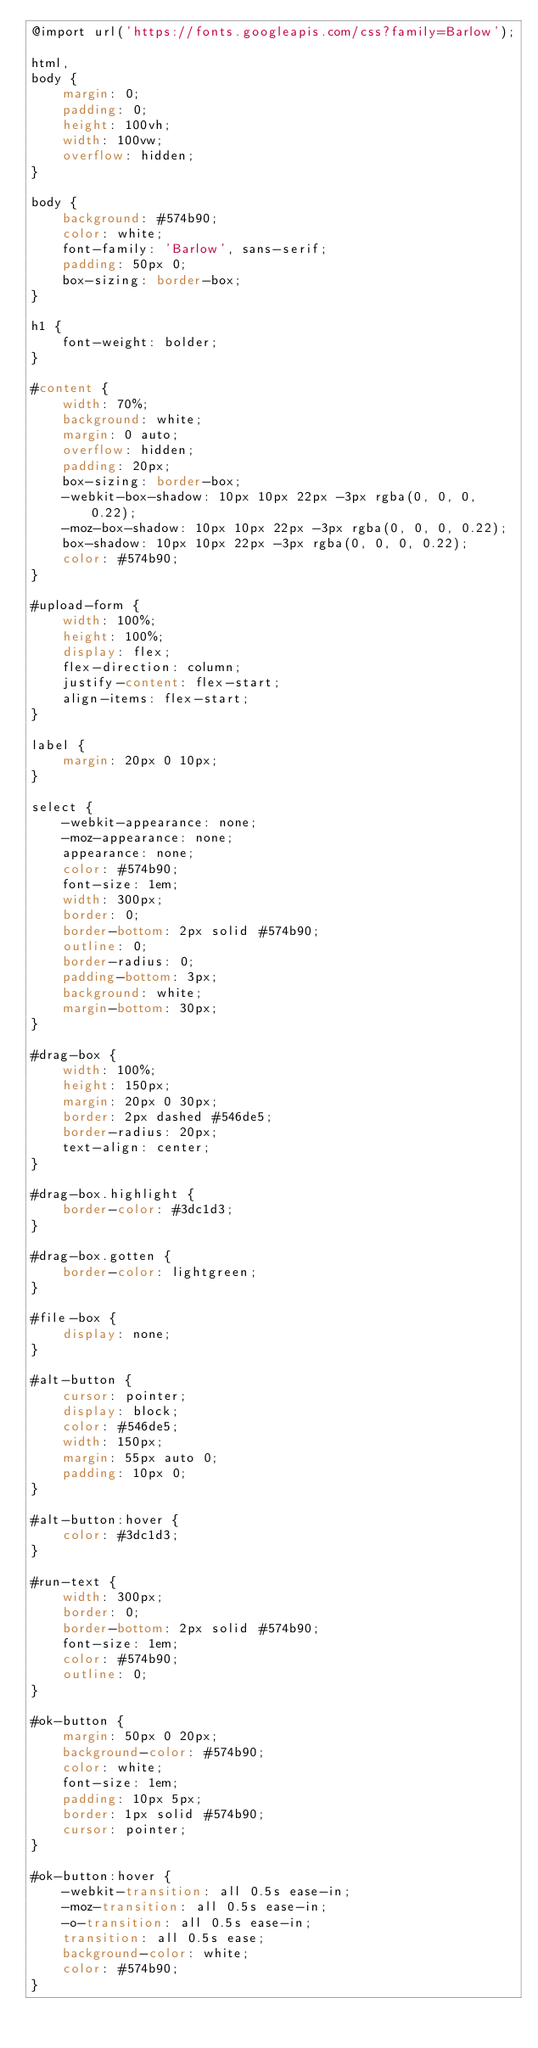<code> <loc_0><loc_0><loc_500><loc_500><_CSS_>@import url('https://fonts.googleapis.com/css?family=Barlow');

html,
body {
    margin: 0;
    padding: 0;
    height: 100vh;
    width: 100vw;
    overflow: hidden;
}

body {
    background: #574b90;
    color: white;
    font-family: 'Barlow', sans-serif;
    padding: 50px 0;
    box-sizing: border-box;
}

h1 {
    font-weight: bolder;
}

#content {
    width: 70%;
    background: white;
    margin: 0 auto;
    overflow: hidden;
    padding: 20px;
    box-sizing: border-box;
    -webkit-box-shadow: 10px 10px 22px -3px rgba(0, 0, 0, 0.22);
    -moz-box-shadow: 10px 10px 22px -3px rgba(0, 0, 0, 0.22);
    box-shadow: 10px 10px 22px -3px rgba(0, 0, 0, 0.22);
    color: #574b90;
}

#upload-form {
    width: 100%;
    height: 100%;
    display: flex;
    flex-direction: column;
    justify-content: flex-start;
    align-items: flex-start;
}

label {
    margin: 20px 0 10px;
}

select {
    -webkit-appearance: none;
    -moz-appearance: none;
    appearance: none;
    color: #574b90;
    font-size: 1em;
    width: 300px;
    border: 0;
    border-bottom: 2px solid #574b90;
    outline: 0;
    border-radius: 0;
    padding-bottom: 3px;
    background: white;
    margin-bottom: 30px;
}

#drag-box {
    width: 100%;
    height: 150px;
    margin: 20px 0 30px;
    border: 2px dashed #546de5;
    border-radius: 20px;
    text-align: center;
}

#drag-box.highlight {
    border-color: #3dc1d3;
}

#drag-box.gotten {
    border-color: lightgreen;
}

#file-box {
    display: none;
}

#alt-button {
    cursor: pointer;
    display: block;
    color: #546de5;
    width: 150px;
    margin: 55px auto 0;
    padding: 10px 0;
}

#alt-button:hover {
    color: #3dc1d3;
}

#run-text {
    width: 300px;
    border: 0;
    border-bottom: 2px solid #574b90;
    font-size: 1em;
    color: #574b90;
    outline: 0;
}

#ok-button {
    margin: 50px 0 20px;
    background-color: #574b90;
    color: white;
    font-size: 1em;
    padding: 10px 5px;
    border: 1px solid #574b90;
    cursor: pointer;
}

#ok-button:hover {
    -webkit-transition: all 0.5s ease-in;
    -moz-transition: all 0.5s ease-in;
    -o-transition: all 0.5s ease-in;
    transition: all 0.5s ease;
    background-color: white;
    color: #574b90;
}</code> 